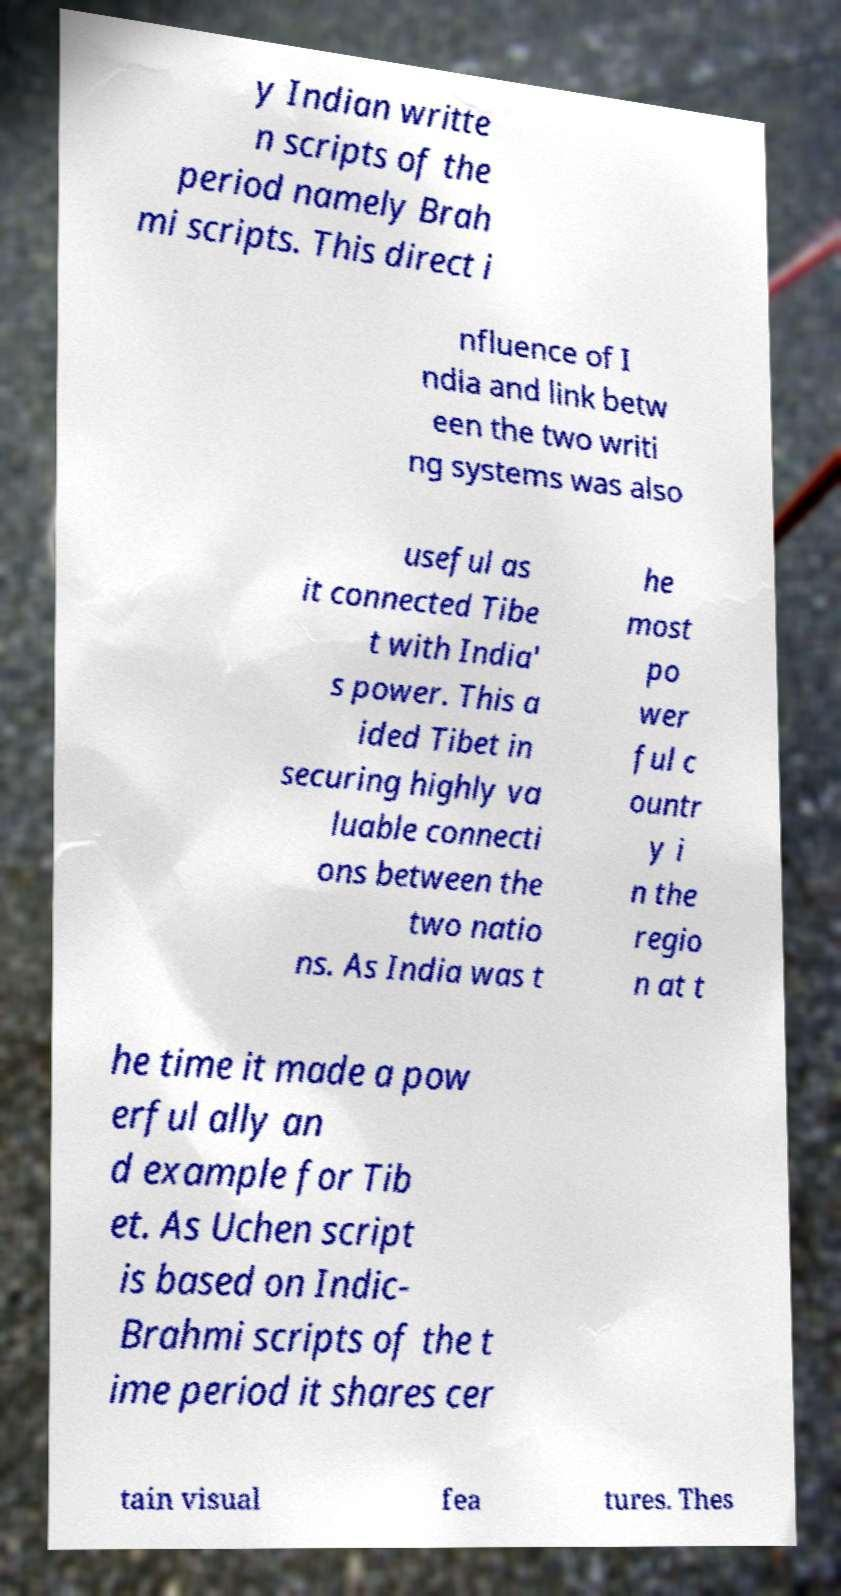I need the written content from this picture converted into text. Can you do that? y Indian writte n scripts of the period namely Brah mi scripts. This direct i nfluence of I ndia and link betw een the two writi ng systems was also useful as it connected Tibe t with India' s power. This a ided Tibet in securing highly va luable connecti ons between the two natio ns. As India was t he most po wer ful c ountr y i n the regio n at t he time it made a pow erful ally an d example for Tib et. As Uchen script is based on Indic- Brahmi scripts of the t ime period it shares cer tain visual fea tures. Thes 